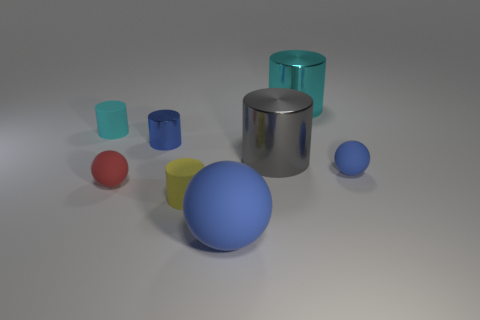What is the shape of the small rubber thing that is the same color as the big ball?
Offer a very short reply. Sphere. There is a large matte thing; is it the same color as the matte sphere on the right side of the big gray cylinder?
Make the answer very short. Yes. Are there any yellow rubber cylinders in front of the red object?
Make the answer very short. Yes. What is the color of the tiny metallic thing that is the same shape as the big cyan object?
Provide a short and direct response. Blue. Are there any other things that have the same shape as the tiny red rubber object?
Keep it short and to the point. Yes. What material is the tiny blue object in front of the small blue shiny cylinder?
Your response must be concise. Rubber. There is another cyan object that is the same shape as the big cyan thing; what size is it?
Provide a succinct answer. Small. What number of blue objects are the same material as the gray thing?
Provide a succinct answer. 1. How many large objects are the same color as the large matte sphere?
Keep it short and to the point. 0. What number of things are either matte things left of the blue cylinder or big shiny objects behind the small cyan rubber cylinder?
Provide a short and direct response. 3. 